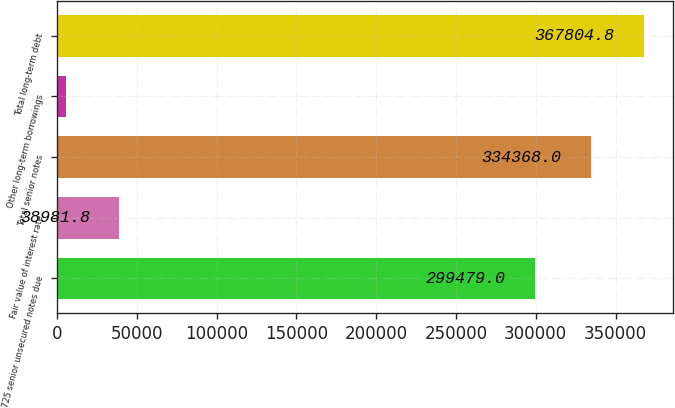<chart> <loc_0><loc_0><loc_500><loc_500><bar_chart><fcel>725 senior unsecured notes due<fcel>Fair value of interest rate<fcel>Total senior notes<fcel>Other long-term borrowings<fcel>Total long-term debt<nl><fcel>299479<fcel>38981.8<fcel>334368<fcel>5545<fcel>367805<nl></chart> 